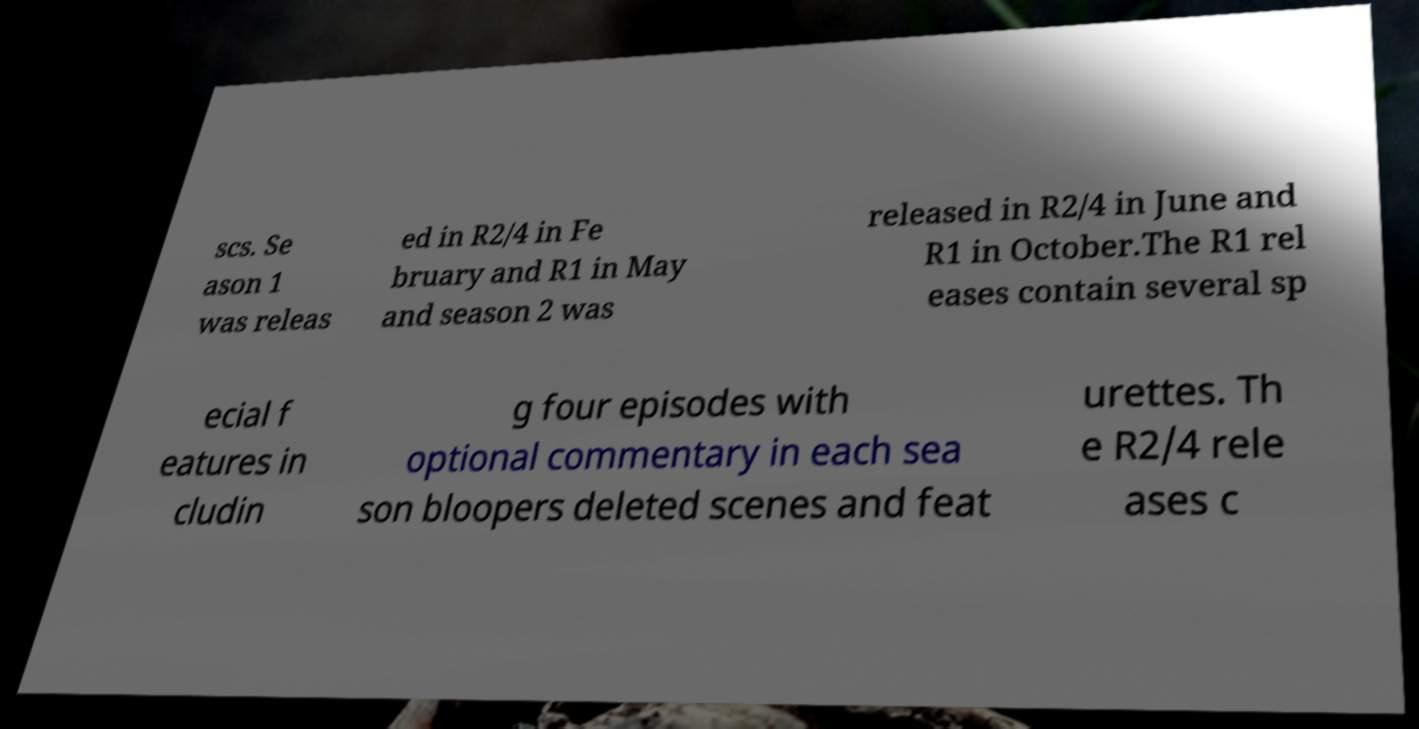Could you assist in decoding the text presented in this image and type it out clearly? scs. Se ason 1 was releas ed in R2/4 in Fe bruary and R1 in May and season 2 was released in R2/4 in June and R1 in October.The R1 rel eases contain several sp ecial f eatures in cludin g four episodes with optional commentary in each sea son bloopers deleted scenes and feat urettes. Th e R2/4 rele ases c 